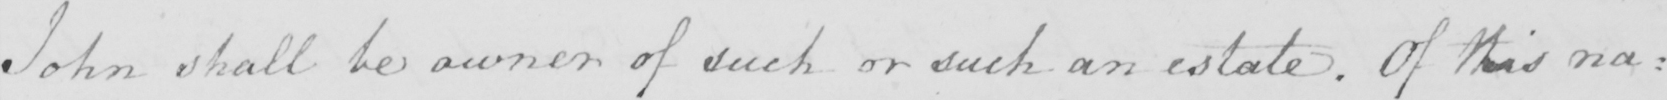What text is written in this handwritten line? John shall be owner of such and such an estate . Of this na : 